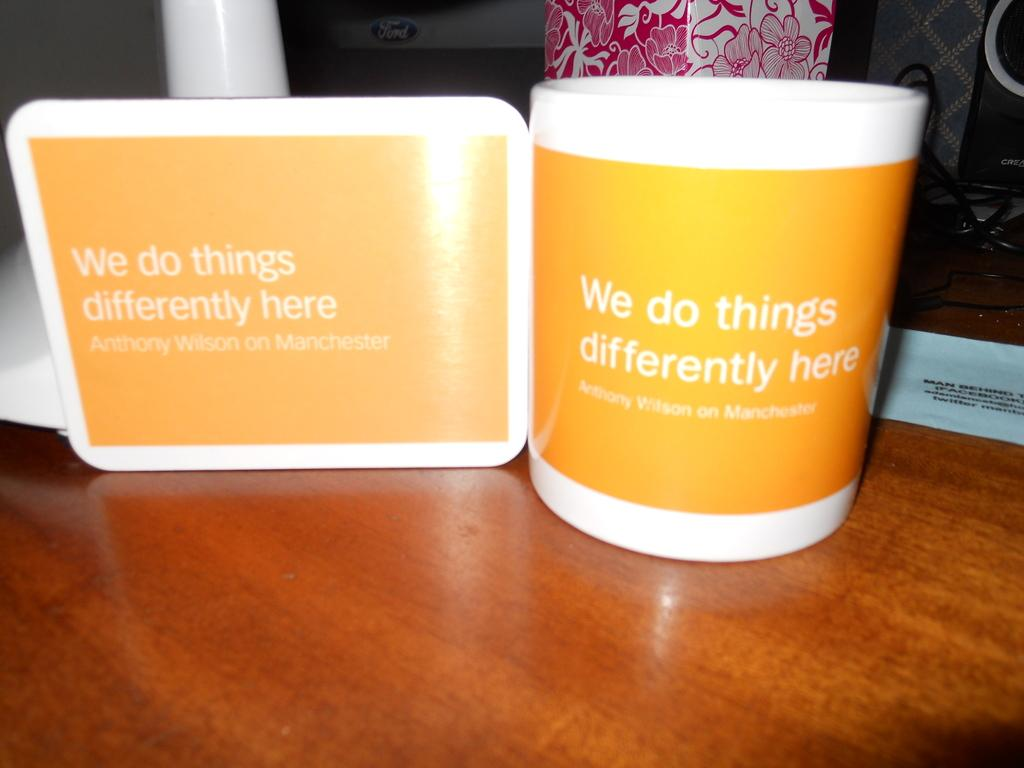<image>
Summarize the visual content of the image. A white and orange mug that says We do things differently here. 